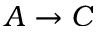Convert formula to latex. <formula><loc_0><loc_0><loc_500><loc_500>A \rightarrow C</formula> 